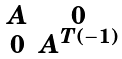Convert formula to latex. <formula><loc_0><loc_0><loc_500><loc_500>\begin{smallmatrix} A & 0 \\ 0 & A ^ { T ( - 1 ) } \end{smallmatrix}</formula> 